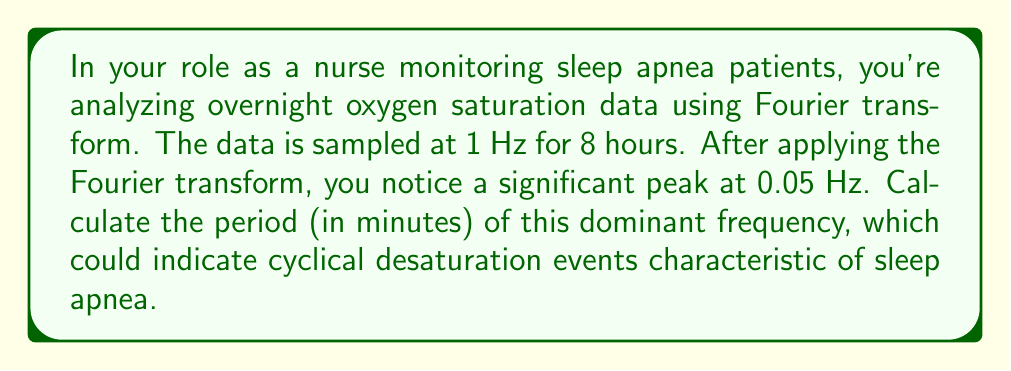What is the answer to this math problem? To solve this problem, we need to understand the relationship between frequency and period, and how to convert between different units.

1) The Fourier transform has revealed a significant peak at 0.05 Hz. This frequency represents the number of cycles per second.

2) The period is the reciprocal of the frequency. In mathematical terms:

   $$T = \frac{1}{f}$$

   where $T$ is the period and $f$ is the frequency.

3) Let's substitute our frequency:

   $$T = \frac{1}{0.05 \text{ Hz}} = 20 \text{ seconds}$$

4) However, we need to express this in minutes. There are 60 seconds in a minute, so:

   $$T = 20 \text{ seconds} \times \frac{1 \text{ minute}}{60 \text{ seconds}} = \frac{1}{3} \text{ minute}$$

5) Therefore, the period of the dominant frequency is $\frac{1}{3}$ or approximately 0.333 minutes.

This period suggests that oxygen desaturation events are occurring about every 20 seconds, which is consistent with moderate to severe sleep apnea patterns.
Answer: $\frac{1}{3}$ minute or approximately 0.333 minutes 